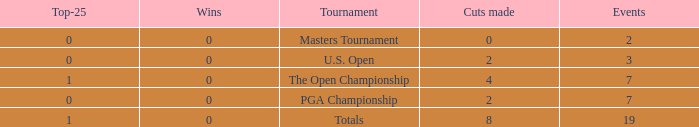What is the lowest Top-25 that has 3 Events and Wins greater than 0? None. 